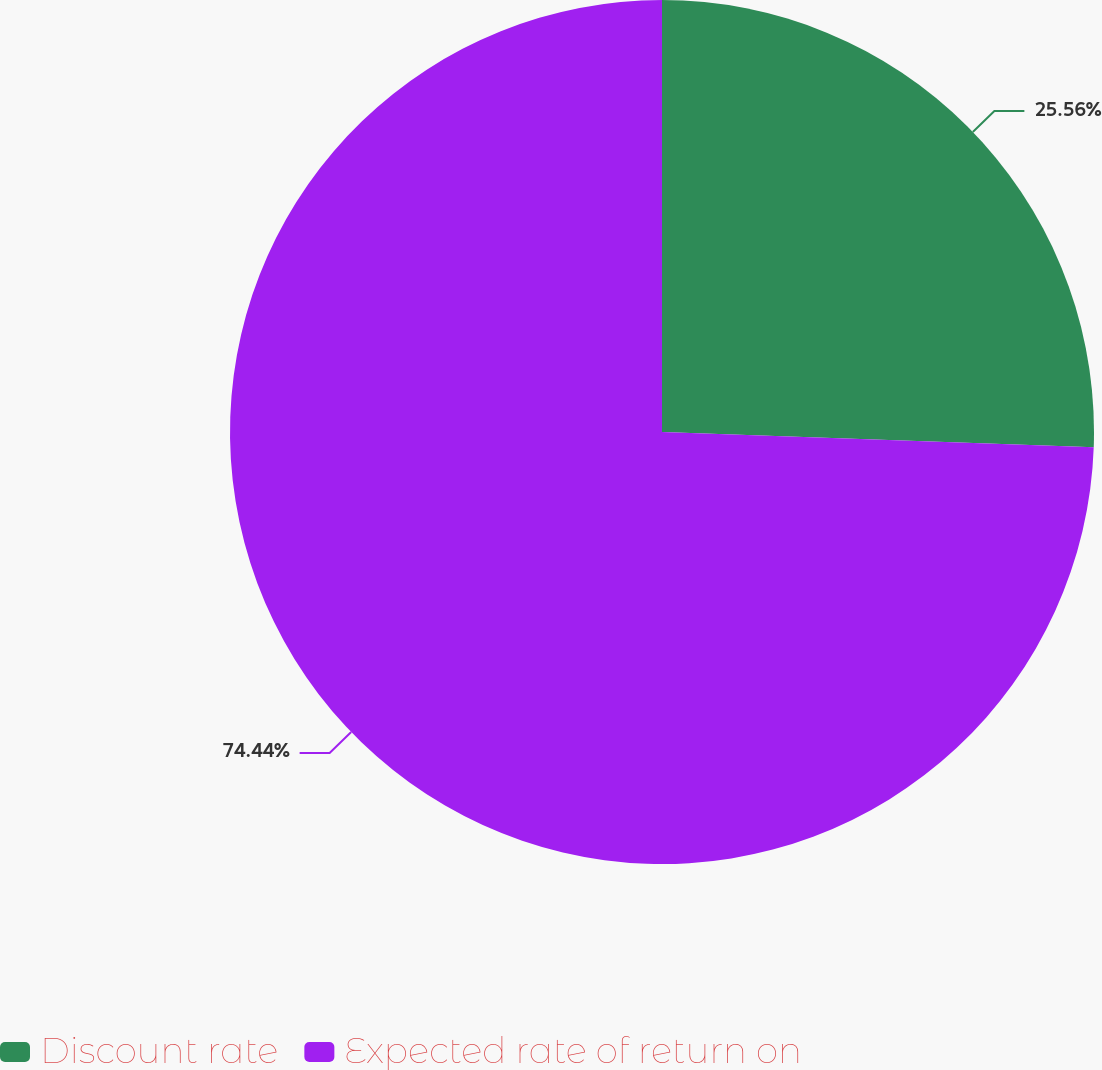Convert chart to OTSL. <chart><loc_0><loc_0><loc_500><loc_500><pie_chart><fcel>Discount rate<fcel>Expected rate of return on<nl><fcel>25.56%<fcel>74.44%<nl></chart> 